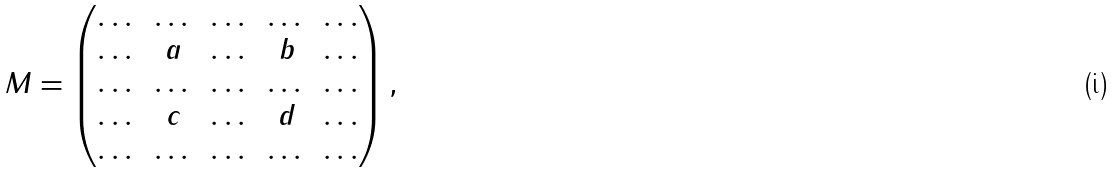Convert formula to latex. <formula><loc_0><loc_0><loc_500><loc_500>M = \begin{pmatrix} \dots & \dots & \dots & \dots & \dots \\ \dots & a & \dots & b & \dots \\ \dots & \dots & \dots & \dots & \dots \\ \dots & c & \dots & d & \dots \\ \dots & \dots & \dots & \dots & \dots \end{pmatrix} ,</formula> 